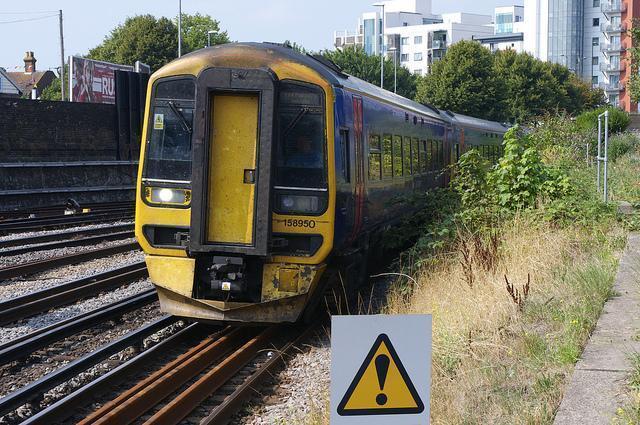How many lights on the train are turned on?
Give a very brief answer. 1. How many warning signs?
Give a very brief answer. 1. 